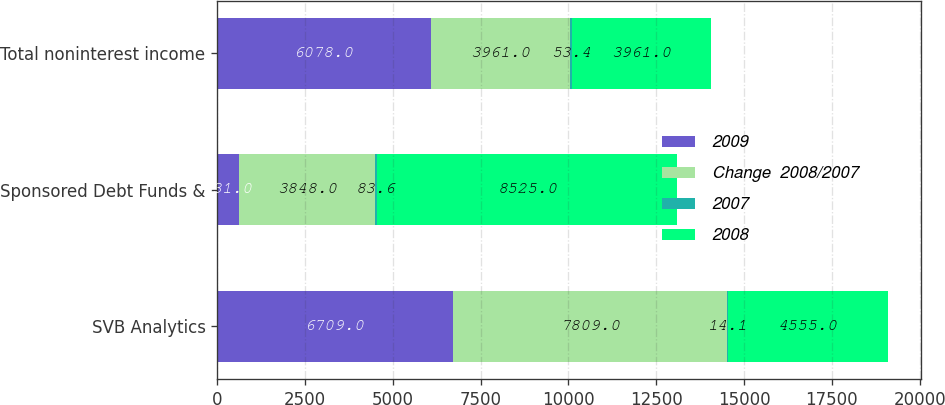<chart> <loc_0><loc_0><loc_500><loc_500><stacked_bar_chart><ecel><fcel>SVB Analytics<fcel>Sponsored Debt Funds &<fcel>Total noninterest income<nl><fcel>2009<fcel>6709<fcel>631<fcel>6078<nl><fcel>Change  2008/2007<fcel>7809<fcel>3848<fcel>3961<nl><fcel>2007<fcel>14.1<fcel>83.6<fcel>53.4<nl><fcel>2008<fcel>4555<fcel>8525<fcel>3961<nl></chart> 